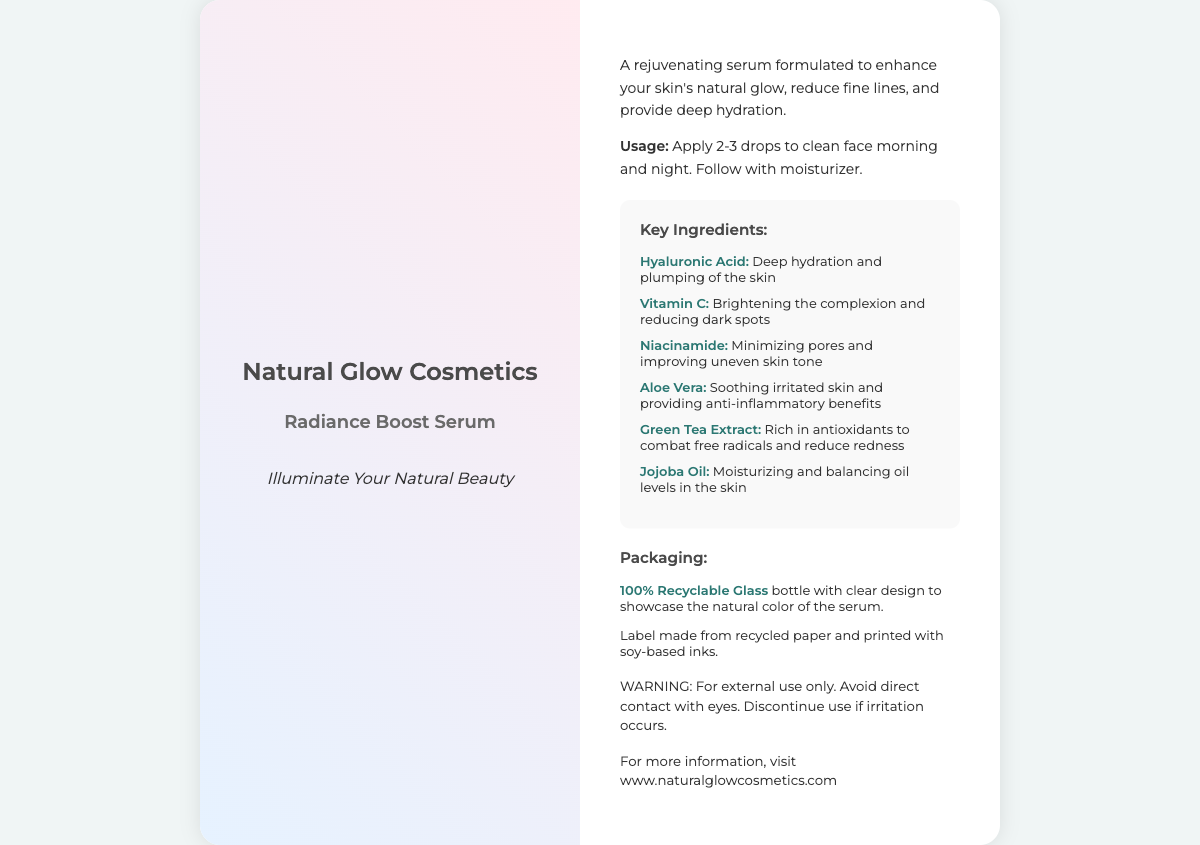What are the key ingredients in the serum? The key ingredients are listed in the ingredients section of the document, highlighting the main components of the product.
Answer: Hyaluronic Acid, Vitamin C, Niacinamide, Aloe Vera, Green Tea Extract, Jojoba Oil What is the primary benefit of Hyaluronic Acid? The document specifies that the primary benefit of Hyaluronic Acid is deep hydration and plumping of the skin.
Answer: Deep hydration and plumping What type of packaging is used for the serum? The packaging section describes the materials used for the product’s packaging, specifically noting its recyclability.
Answer: 100% Recyclable Glass What is the suggested usage of the serum? The usage section provides instructions on how to apply the serum for optimal results.
Answer: Apply 2-3 drops to clean face morning and night Which ingredient is known for brightening the complexion? The ingredients list includes a specific ingredient noted for its brightening effect on the skin.
Answer: Vitamin C What alternative use does Aloe Vera provide in the serum? Besides its main benefit, the document mentions an additional property of Aloe Vera.
Answer: Soothing irritated skin Why is Green Tea Extract included in the serum? The explanation in the ingredients list indicates that Green Tea Extract has specific beneficial properties.
Answer: Rich in antioxidants What ink is used for the labeling of the product? The packaging details mention the type of ink used for printing the label, which is an eco-friendly characteristic.
Answer: Soy-based inks 